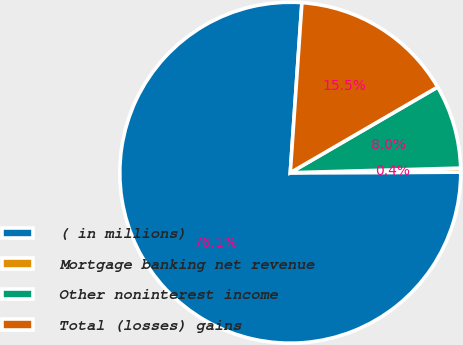<chart> <loc_0><loc_0><loc_500><loc_500><pie_chart><fcel>( in millions)<fcel>Mortgage banking net revenue<fcel>Other noninterest income<fcel>Total (losses) gains<nl><fcel>76.14%<fcel>0.38%<fcel>7.95%<fcel>15.53%<nl></chart> 